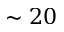Convert formula to latex. <formula><loc_0><loc_0><loc_500><loc_500>\sim 2 0</formula> 